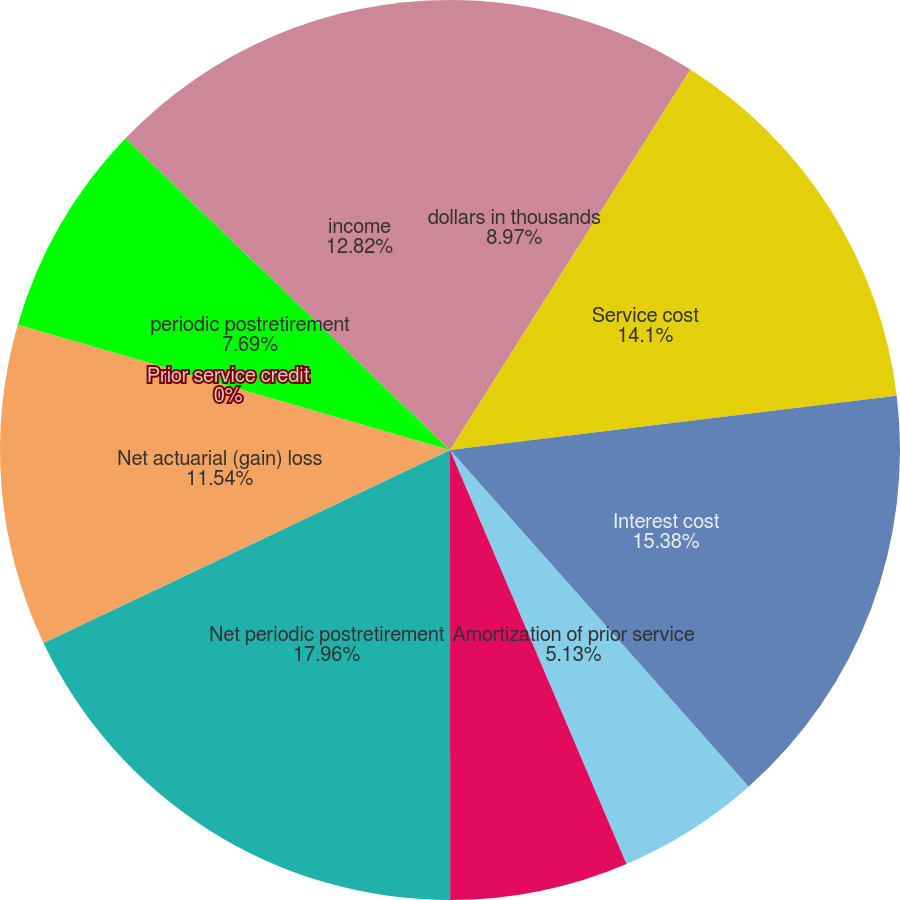Convert chart. <chart><loc_0><loc_0><loc_500><loc_500><pie_chart><fcel>dollars in thousands<fcel>Service cost<fcel>Interest cost<fcel>Amortization of prior service<fcel>Amortization of actuarial loss<fcel>Net periodic postretirement<fcel>Net actuarial (gain) loss<fcel>Prior service credit<fcel>periodic postretirement<fcel>income<nl><fcel>8.97%<fcel>14.1%<fcel>15.38%<fcel>5.13%<fcel>6.41%<fcel>17.95%<fcel>11.54%<fcel>0.0%<fcel>7.69%<fcel>12.82%<nl></chart> 